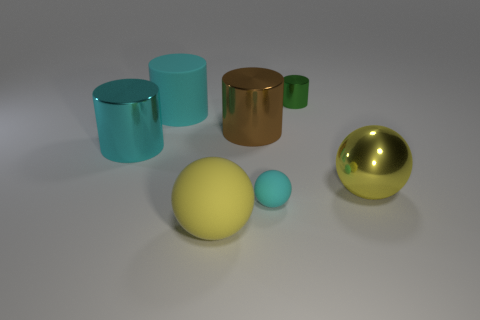What number of other big things are the same shape as the yellow metallic object?
Ensure brevity in your answer.  1. There is a object that is in front of the rubber ball that is behind the yellow sphere that is left of the big brown cylinder; what is its size?
Provide a short and direct response. Large. Is the number of tiny cyan things that are behind the small matte ball greater than the number of small cyan cylinders?
Offer a terse response. No. Are there any tiny gray metallic cubes?
Your answer should be very brief. No. How many green objects have the same size as the cyan ball?
Keep it short and to the point. 1. Are there more large brown objects that are in front of the cyan metal thing than tiny green cylinders that are right of the tiny green cylinder?
Offer a very short reply. No. There is a brown thing that is the same size as the cyan rubber cylinder; what is its material?
Provide a short and direct response. Metal. What is the shape of the green thing?
Provide a succinct answer. Cylinder. What number of green things are either matte cylinders or big cylinders?
Your answer should be compact. 0. What is the size of the sphere that is the same material as the small green object?
Offer a very short reply. Large. 